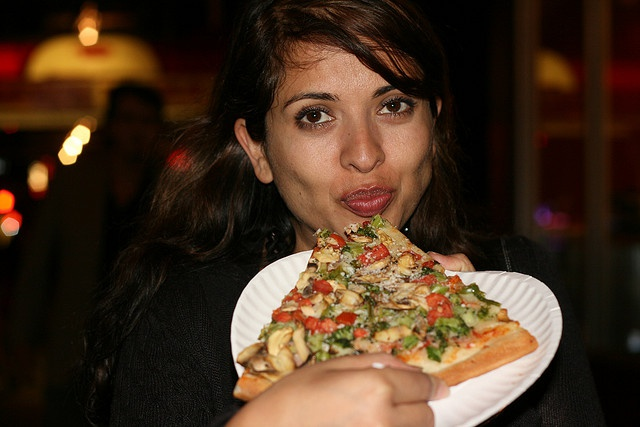Describe the objects in this image and their specific colors. I can see people in black, salmon, tan, and lightgray tones, pizza in black, tan, brown, and olive tones, and people in black, maroon, gold, and khaki tones in this image. 